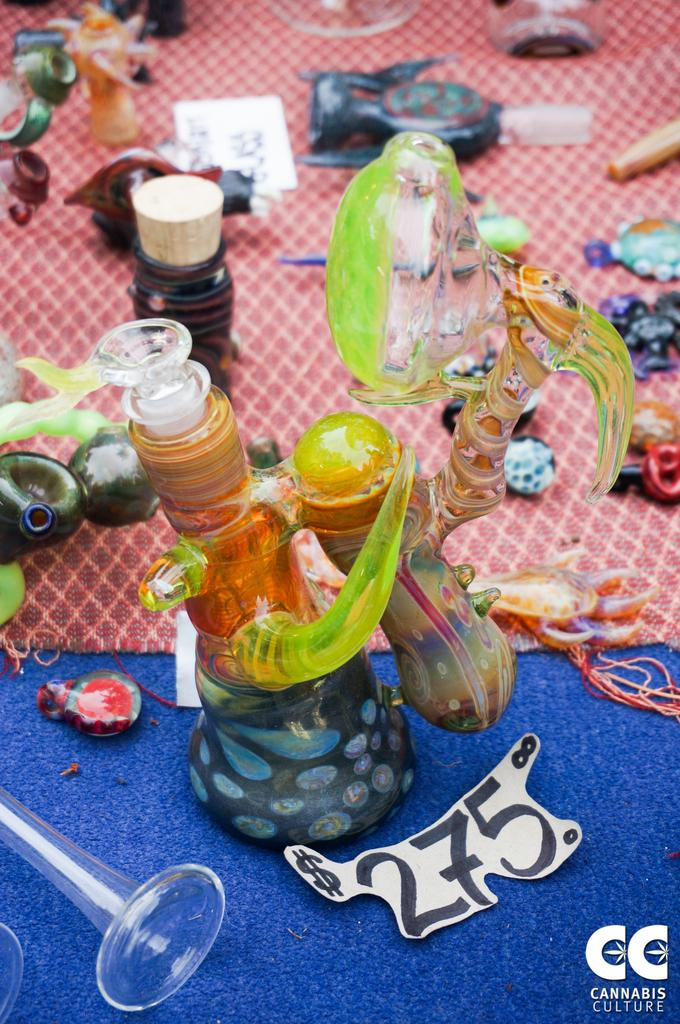What type of toys can be seen in the image? There are toys in the image, but the specific type cannot be determined from the facts provided. What is the bottle in the image used for? The purpose of the bottle in the image cannot be determined from the facts provided. What is the ball in the image used for? The purpose of the ball in the image cannot be determined from the facts provided. What other objects can be seen on the floor in the image? There are other objects on the floor in the image, but their specific nature cannot be determined from the facts provided. How many letters are being stamped on the toys in the image? There are no letters or stamps present in the image; it only contains toys, a bottle, a ball, a glass, and other objects on the floor. 